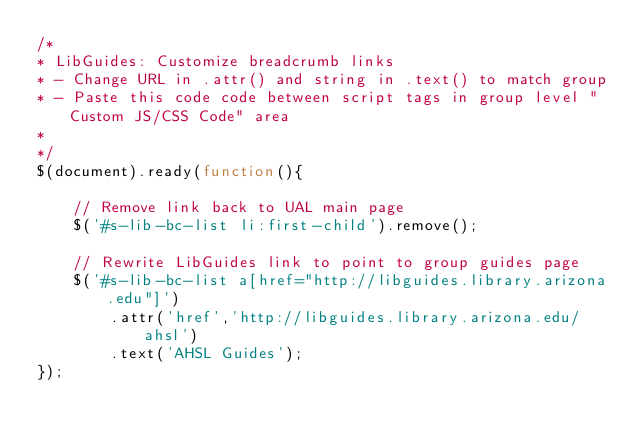<code> <loc_0><loc_0><loc_500><loc_500><_JavaScript_>/*
* LibGuides: Customize breadcrumb links
* - Change URL in .attr() and string in .text() to match group
* - Paste this code code between script tags in group level "Custom JS/CSS Code" area
*
*/
$(document).ready(function(){

    // Remove link back to UAL main page
    $('#s-lib-bc-list li:first-child').remove();

    // Rewrite LibGuides link to point to group guides page
    $('#s-lib-bc-list a[href="http://libguides.library.arizona.edu"]')
        .attr('href','http://libguides.library.arizona.edu/ahsl')
        .text('AHSL Guides');
});</code> 